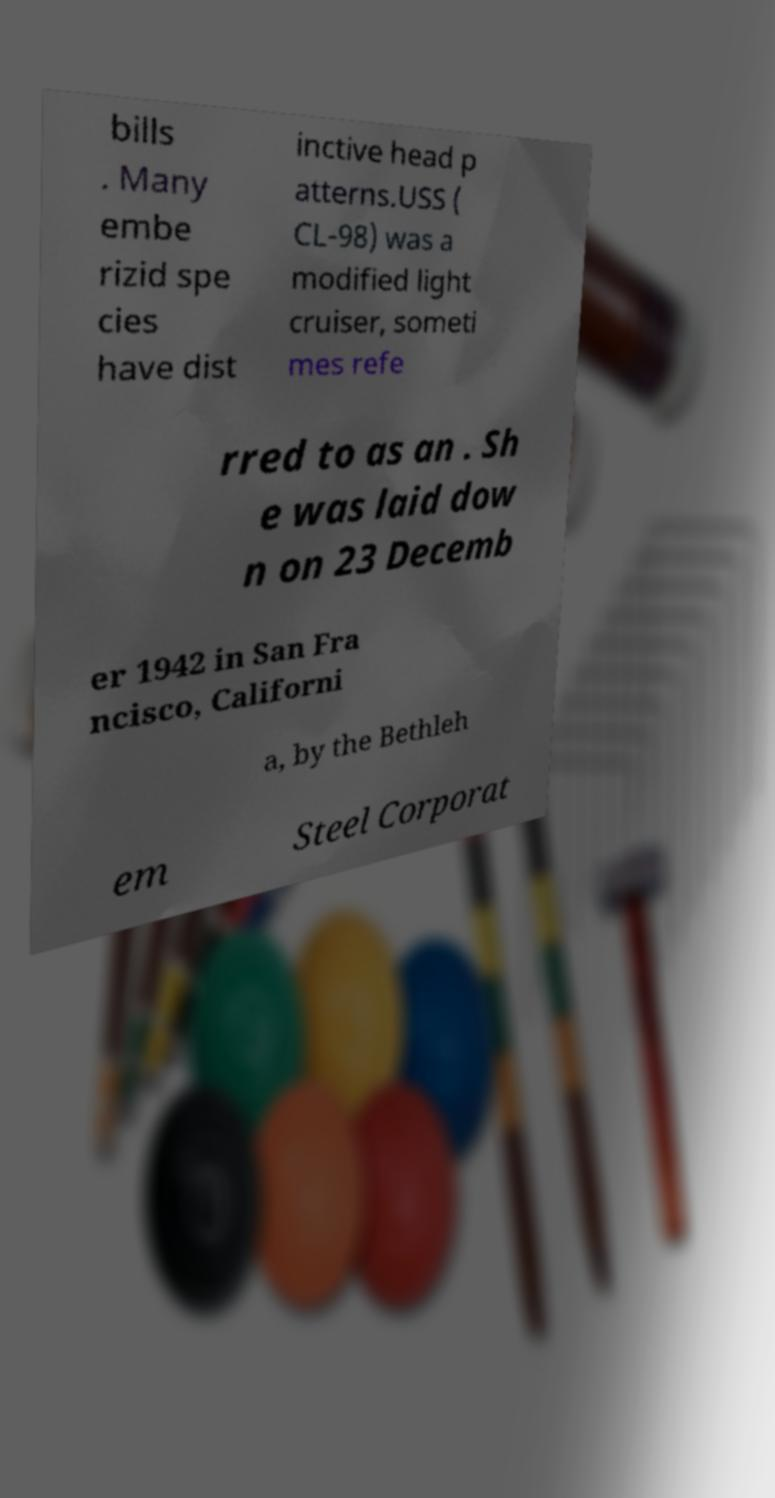Please read and relay the text visible in this image. What does it say? bills . Many embe rizid spe cies have dist inctive head p atterns.USS ( CL-98) was a modified light cruiser, someti mes refe rred to as an . Sh e was laid dow n on 23 Decemb er 1942 in San Fra ncisco, Californi a, by the Bethleh em Steel Corporat 